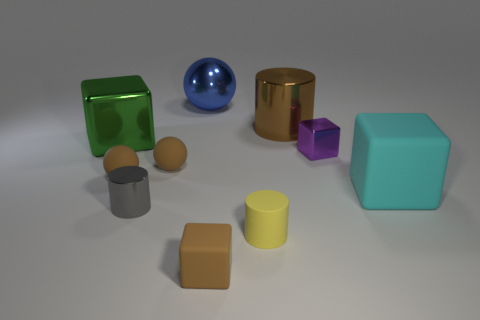Subtract all gray blocks. Subtract all green spheres. How many blocks are left? 4 Subtract all spheres. How many objects are left? 7 Subtract all small metal cubes. Subtract all cyan objects. How many objects are left? 8 Add 4 large brown metal cylinders. How many large brown metal cylinders are left? 5 Add 5 big green metallic objects. How many big green metallic objects exist? 6 Subtract 2 brown spheres. How many objects are left? 8 